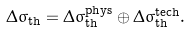<formula> <loc_0><loc_0><loc_500><loc_500>\Delta \sigma _ { \text {th} } = \Delta \sigma ^ { \text {phys} } _ { \text {th} } \oplus \Delta \sigma ^ { \text {tech} } _ { \text {th} } .</formula> 